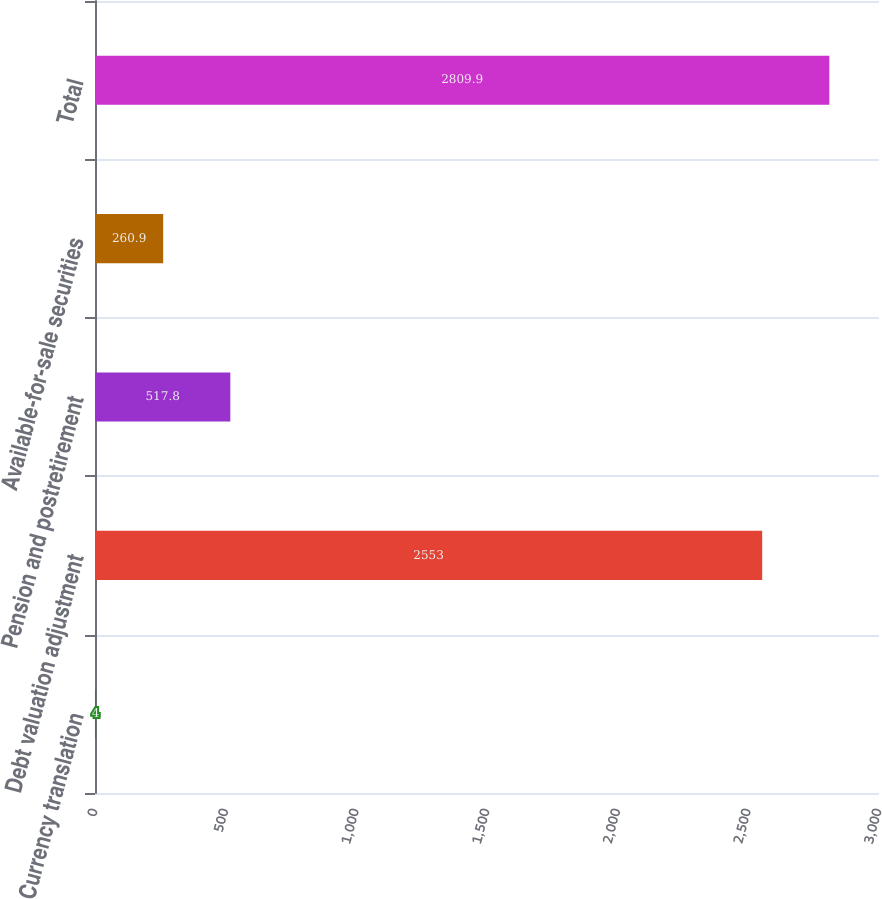Convert chart. <chart><loc_0><loc_0><loc_500><loc_500><bar_chart><fcel>Currency translation<fcel>Debt valuation adjustment<fcel>Pension and postretirement<fcel>Available-for-sale securities<fcel>Total<nl><fcel>4<fcel>2553<fcel>517.8<fcel>260.9<fcel>2809.9<nl></chart> 